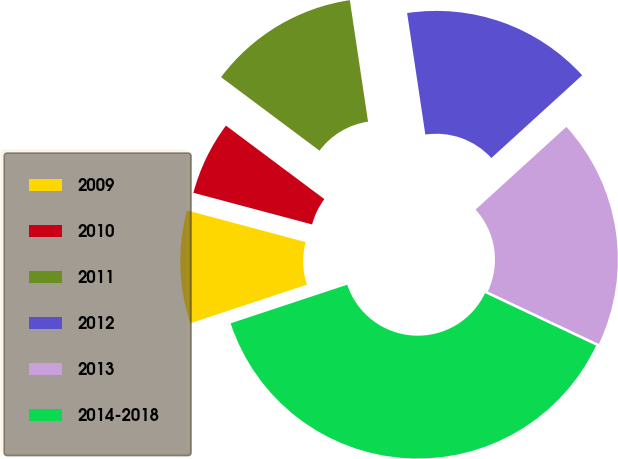Convert chart to OTSL. <chart><loc_0><loc_0><loc_500><loc_500><pie_chart><fcel>2009<fcel>2010<fcel>2011<fcel>2012<fcel>2013<fcel>2014-2018<nl><fcel>9.24%<fcel>6.06%<fcel>12.42%<fcel>15.61%<fcel>18.79%<fcel>37.88%<nl></chart> 